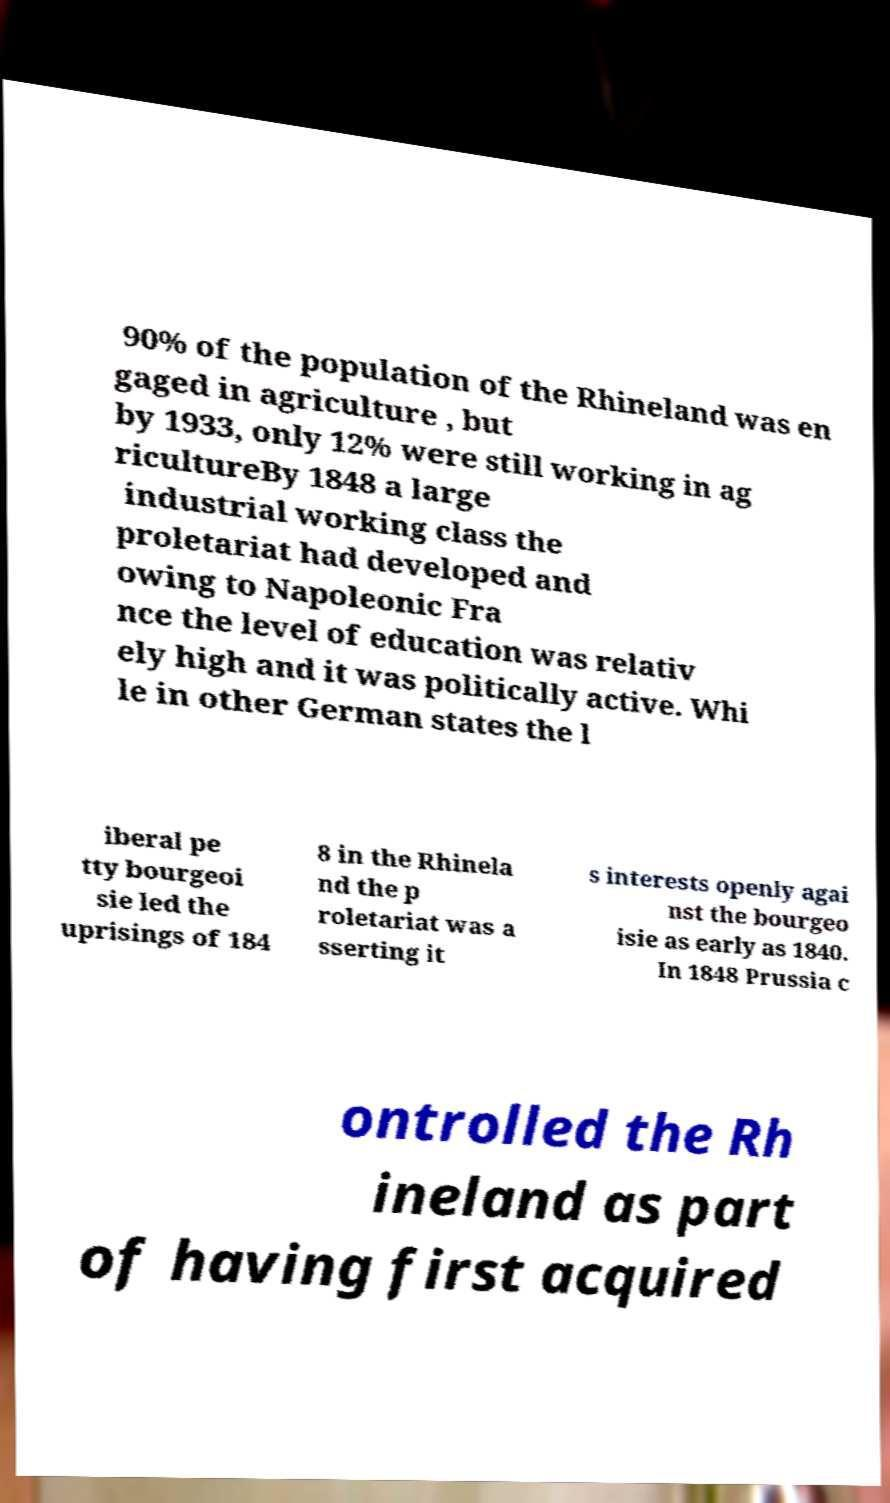Please identify and transcribe the text found in this image. 90% of the population of the Rhineland was en gaged in agriculture , but by 1933, only 12% were still working in ag ricultureBy 1848 a large industrial working class the proletariat had developed and owing to Napoleonic Fra nce the level of education was relativ ely high and it was politically active. Whi le in other German states the l iberal pe tty bourgeoi sie led the uprisings of 184 8 in the Rhinela nd the p roletariat was a sserting it s interests openly agai nst the bourgeo isie as early as 1840. In 1848 Prussia c ontrolled the Rh ineland as part of having first acquired 